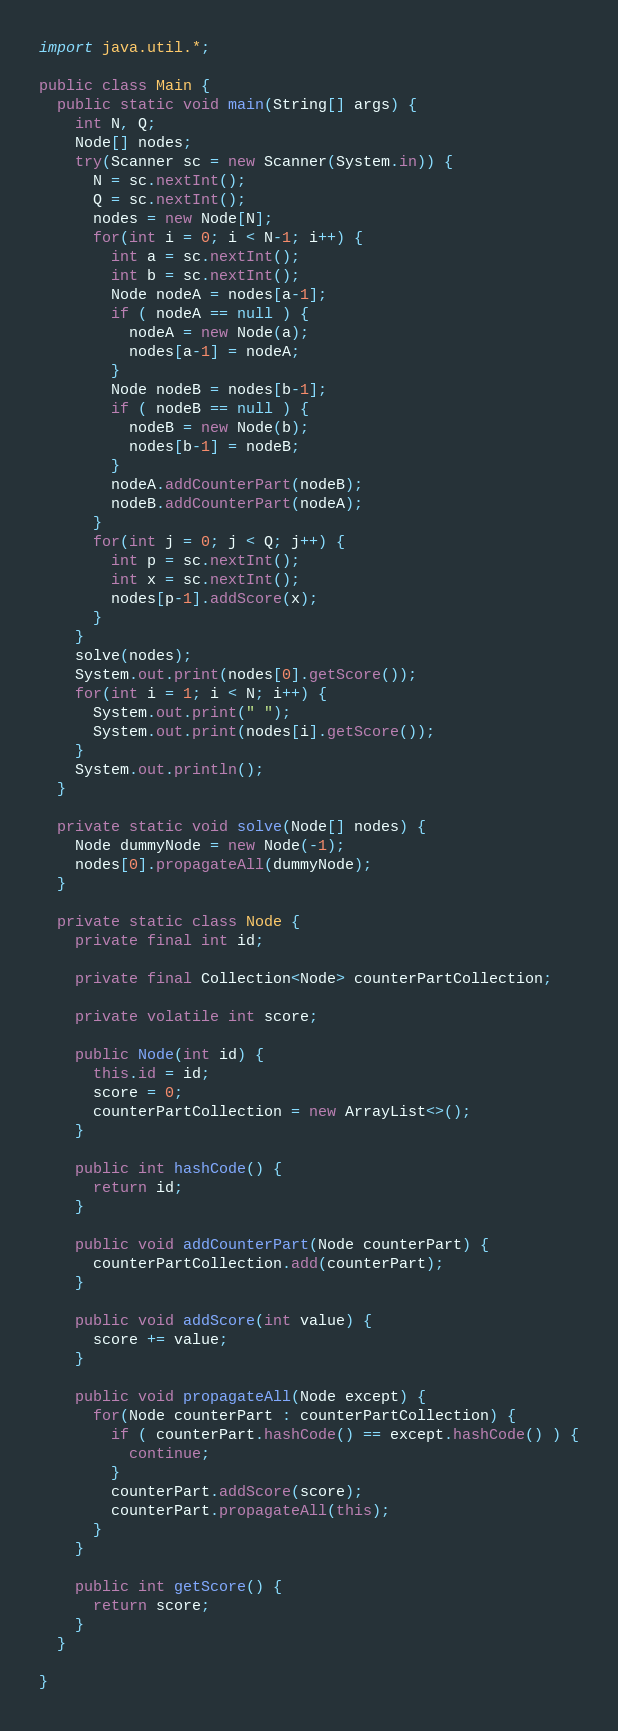<code> <loc_0><loc_0><loc_500><loc_500><_Java_>import java.util.*;

public class Main {
  public static void main(String[] args) {
    int N, Q;
    Node[] nodes;
    try(Scanner sc = new Scanner(System.in)) {
      N = sc.nextInt();
      Q = sc.nextInt();
      nodes = new Node[N];
      for(int i = 0; i < N-1; i++) {
        int a = sc.nextInt();
        int b = sc.nextInt();
        Node nodeA = nodes[a-1];
        if ( nodeA == null ) {
          nodeA = new Node(a);
          nodes[a-1] = nodeA;
        }
        Node nodeB = nodes[b-1];
        if ( nodeB == null ) {
          nodeB = new Node(b);
          nodes[b-1] = nodeB;
        }
        nodeA.addCounterPart(nodeB);
        nodeB.addCounterPart(nodeA);
      }
      for(int j = 0; j < Q; j++) {
        int p = sc.nextInt();
        int x = sc.nextInt();
        nodes[p-1].addScore(x);
      }
    }
    solve(nodes);
    System.out.print(nodes[0].getScore());
    for(int i = 1; i < N; i++) {
      System.out.print(" ");
      System.out.print(nodes[i].getScore());
    }
    System.out.println();
  }
  
  private static void solve(Node[] nodes) {
    Node dummyNode = new Node(-1);
    nodes[0].propagateAll(dummyNode);
  }
  
  private static class Node {
    private final int id;
    
    private final Collection<Node> counterPartCollection;
    
    private volatile int score;
    
    public Node(int id) {
      this.id = id;
      score = 0;
      counterPartCollection = new ArrayList<>();
    }
    
    public int hashCode() {
      return id;
    }
    
    public void addCounterPart(Node counterPart) {
      counterPartCollection.add(counterPart);
    }
    
    public void addScore(int value) {
      score += value;
    }
    
    public void propagateAll(Node except) {
      for(Node counterPart : counterPartCollection) {
        if ( counterPart.hashCode() == except.hashCode() ) {
          continue;
        }
        counterPart.addScore(score);
        counterPart.propagateAll(this);
      }
    }

    public int getScore() {
      return score;
    }
  }

}
</code> 